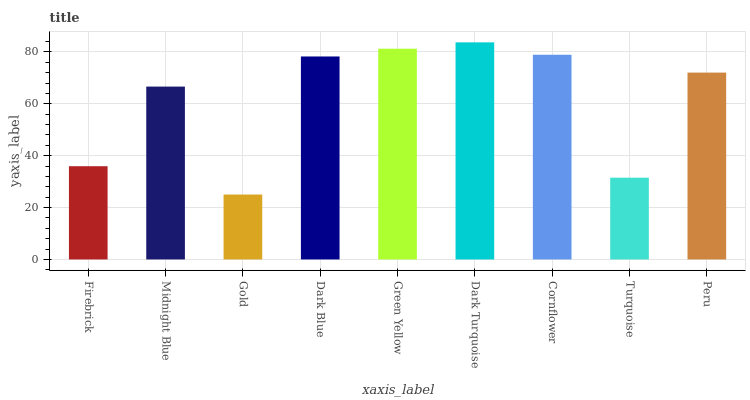Is Gold the minimum?
Answer yes or no. Yes. Is Dark Turquoise the maximum?
Answer yes or no. Yes. Is Midnight Blue the minimum?
Answer yes or no. No. Is Midnight Blue the maximum?
Answer yes or no. No. Is Midnight Blue greater than Firebrick?
Answer yes or no. Yes. Is Firebrick less than Midnight Blue?
Answer yes or no. Yes. Is Firebrick greater than Midnight Blue?
Answer yes or no. No. Is Midnight Blue less than Firebrick?
Answer yes or no. No. Is Peru the high median?
Answer yes or no. Yes. Is Peru the low median?
Answer yes or no. Yes. Is Gold the high median?
Answer yes or no. No. Is Midnight Blue the low median?
Answer yes or no. No. 